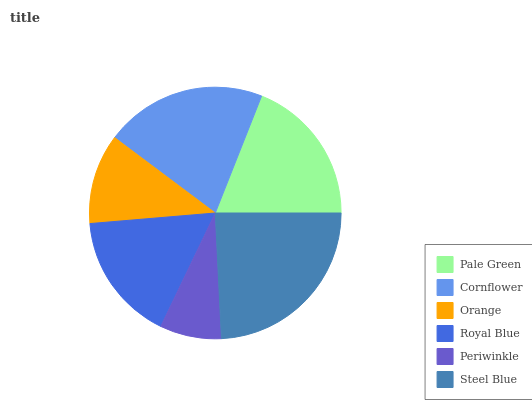Is Periwinkle the minimum?
Answer yes or no. Yes. Is Steel Blue the maximum?
Answer yes or no. Yes. Is Cornflower the minimum?
Answer yes or no. No. Is Cornflower the maximum?
Answer yes or no. No. Is Cornflower greater than Pale Green?
Answer yes or no. Yes. Is Pale Green less than Cornflower?
Answer yes or no. Yes. Is Pale Green greater than Cornflower?
Answer yes or no. No. Is Cornflower less than Pale Green?
Answer yes or no. No. Is Pale Green the high median?
Answer yes or no. Yes. Is Royal Blue the low median?
Answer yes or no. Yes. Is Periwinkle the high median?
Answer yes or no. No. Is Steel Blue the low median?
Answer yes or no. No. 